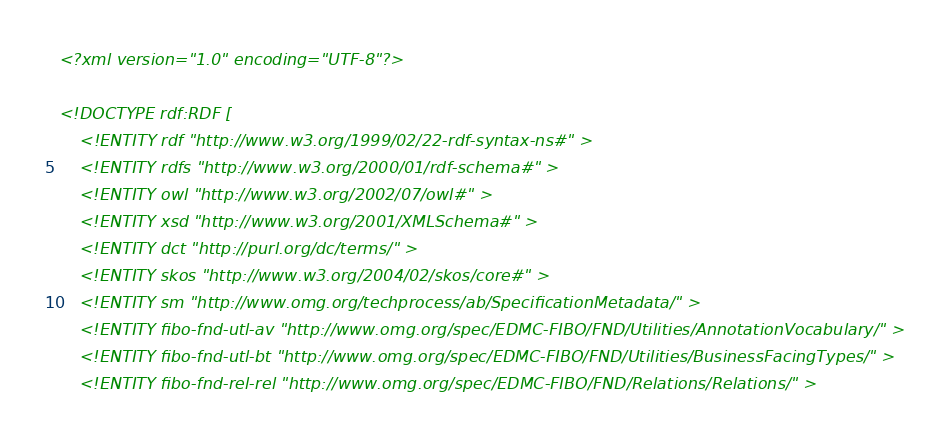<code> <loc_0><loc_0><loc_500><loc_500><_XML_><?xml version="1.0" encoding="UTF-8"?>

<!DOCTYPE rdf:RDF [
    <!ENTITY rdf "http://www.w3.org/1999/02/22-rdf-syntax-ns#" >
    <!ENTITY rdfs "http://www.w3.org/2000/01/rdf-schema#" >
    <!ENTITY owl "http://www.w3.org/2002/07/owl#" >
    <!ENTITY xsd "http://www.w3.org/2001/XMLSchema#" >
    <!ENTITY dct "http://purl.org/dc/terms/" >
    <!ENTITY skos "http://www.w3.org/2004/02/skos/core#" >
    <!ENTITY sm "http://www.omg.org/techprocess/ab/SpecificationMetadata/" >
    <!ENTITY fibo-fnd-utl-av "http://www.omg.org/spec/EDMC-FIBO/FND/Utilities/AnnotationVocabulary/" >
    <!ENTITY fibo-fnd-utl-bt "http://www.omg.org/spec/EDMC-FIBO/FND/Utilities/BusinessFacingTypes/" >
    <!ENTITY fibo-fnd-rel-rel "http://www.omg.org/spec/EDMC-FIBO/FND/Relations/Relations/" ></code> 